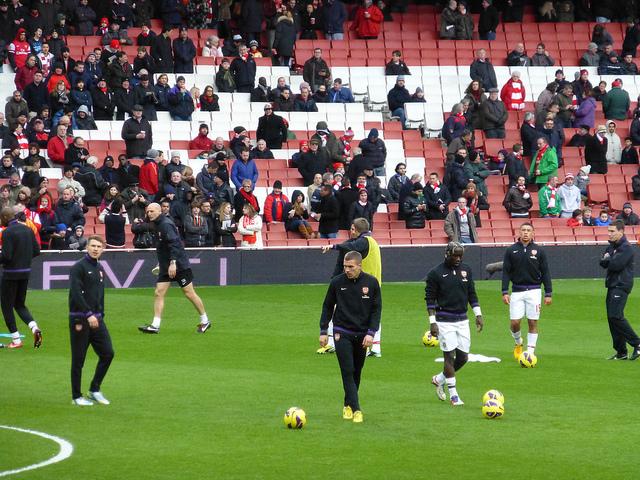What sport do these men play?
Write a very short answer. Soccer. What color is the ball?
Short answer required. Yellow. How many people are wearing pants on the field?
Concise answer only. 4. 